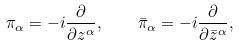Convert formula to latex. <formula><loc_0><loc_0><loc_500><loc_500>\pi _ { \alpha } = - i \frac { \partial } { \partial z ^ { \alpha } } , \quad \bar { \pi } _ { \alpha } = - i \frac { \partial } { \partial { \bar { z } } ^ { \alpha } } ,</formula> 